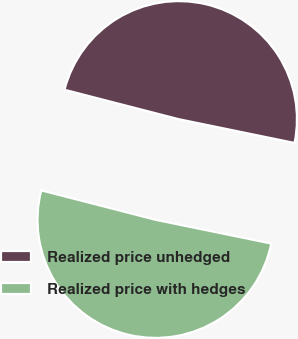<chart> <loc_0><loc_0><loc_500><loc_500><pie_chart><fcel>Realized price unhedged<fcel>Realized price with hedges<nl><fcel>49.21%<fcel>50.79%<nl></chart> 